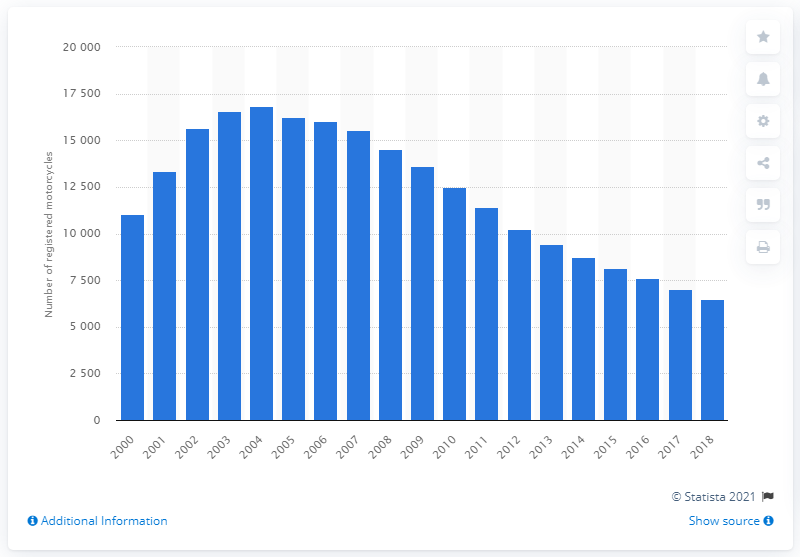List a handful of essential elements in this visual. In 2018, a total of 6,505 Honda CBR600F motorcycles were registered in Great Britain. 